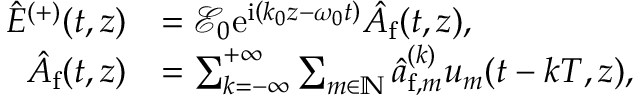Convert formula to latex. <formula><loc_0><loc_0><loc_500><loc_500>\begin{array} { r l } { \hat { E } ^ { ( + ) } ( t , z ) } & { = \mathcal { E } _ { 0 } e ^ { i \left ( k _ { 0 } z - \omega _ { 0 } t \right ) } \hat { A } _ { f } ( t , z ) , } \\ { \hat { A } _ { f } ( t , z ) } & { = \sum _ { k = - \infty } ^ { + \infty } \sum _ { m \in \mathbb { N } } \hat { a } _ { f , m } ^ { ( k ) } u _ { m } ( t - k T , z ) , } \end{array}</formula> 